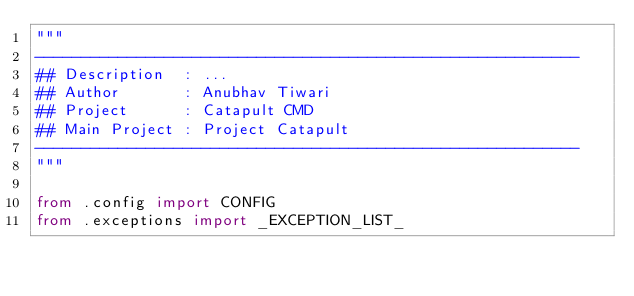Convert code to text. <code><loc_0><loc_0><loc_500><loc_500><_Python_>"""
-----------------------------------------------------------
## Description  : ...
## Author       : Anubhav Tiwari
## Project      : Catapult CMD
## Main Project : Project Catapult
-----------------------------------------------------------
"""

from .config import CONFIG
from .exceptions import _EXCEPTION_LIST_</code> 